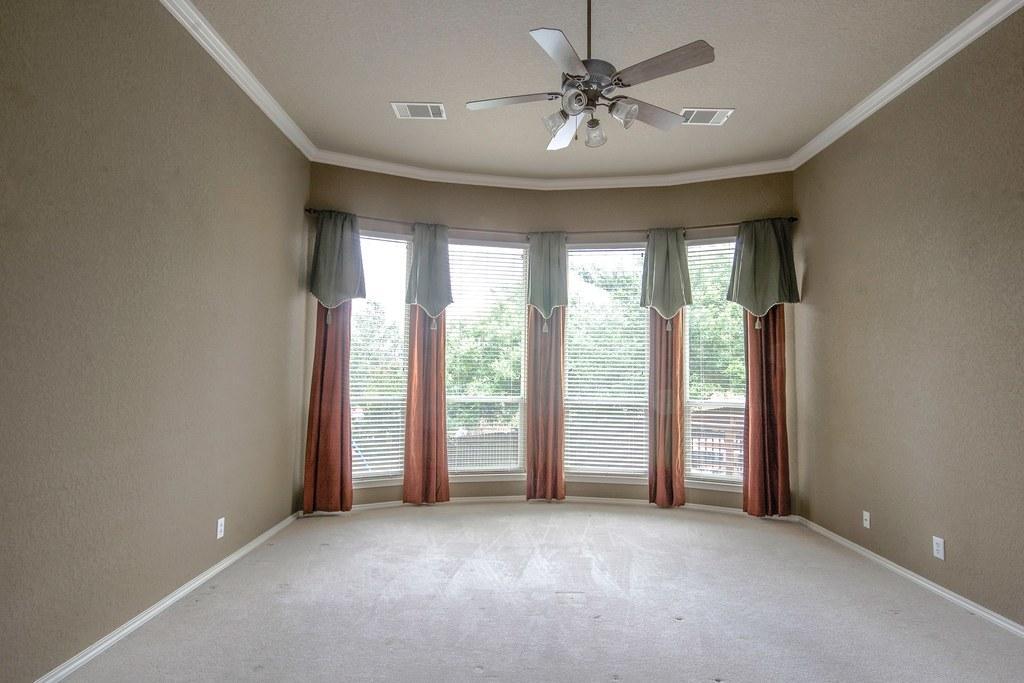Please provide a concise description of this image. In this image we can see ceiling fan and at the background of the image there is glass door, curtains and we can see some trees through the door. 